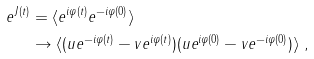<formula> <loc_0><loc_0><loc_500><loc_500>e ^ { J ( t ) } & = \langle e ^ { i \varphi ( t ) } e ^ { - i \varphi ( 0 ) } \rangle \\ & \rightarrow \langle ( u e ^ { - i \varphi ( t ) } - v e ^ { i \varphi ( t ) } ) ( u e ^ { i \varphi ( 0 ) } - v e ^ { - i \varphi ( 0 ) } ) \rangle \ ,</formula> 